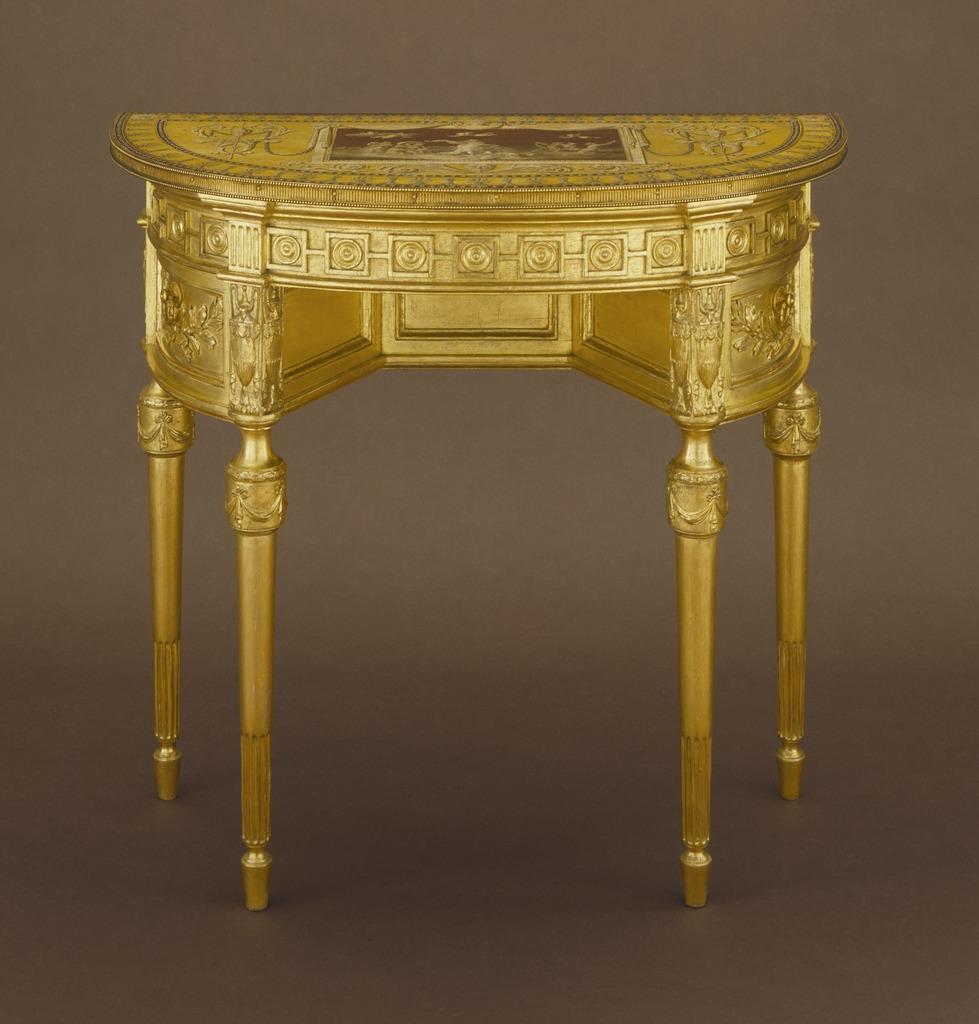Describe this image in one or two sentences. This is a zoomed in picture. In the center there is a golden color table placed on the ground. 